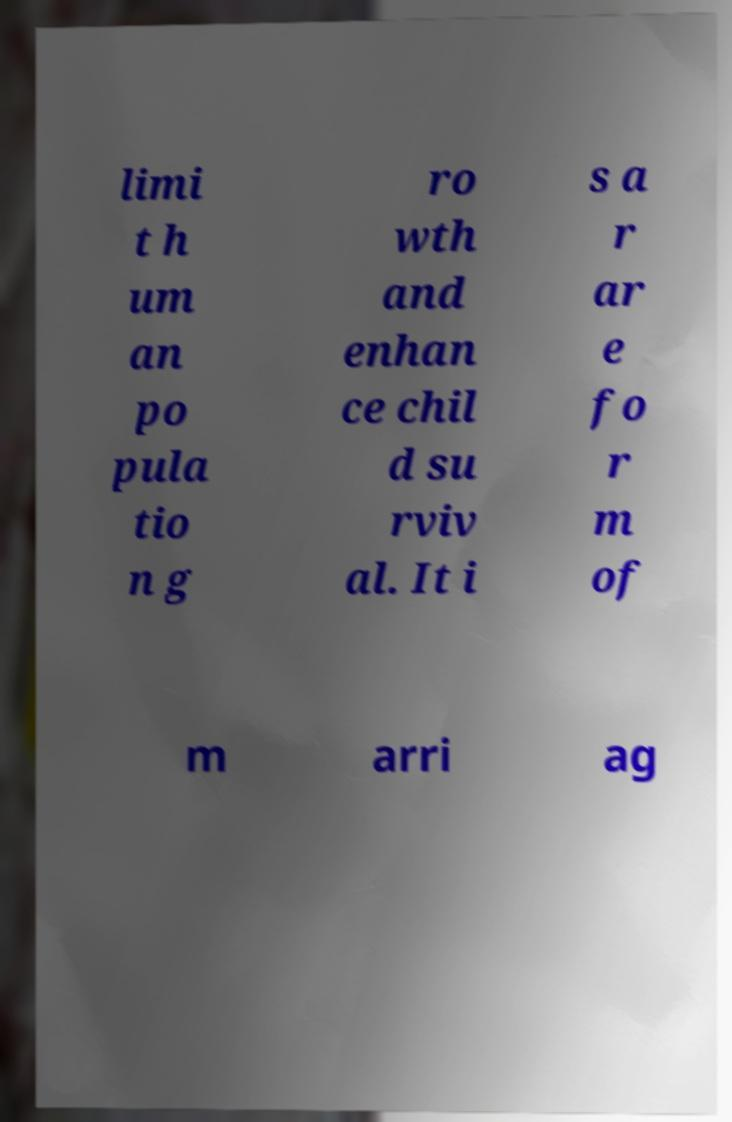Please identify and transcribe the text found in this image. limi t h um an po pula tio n g ro wth and enhan ce chil d su rviv al. It i s a r ar e fo r m of m arri ag 